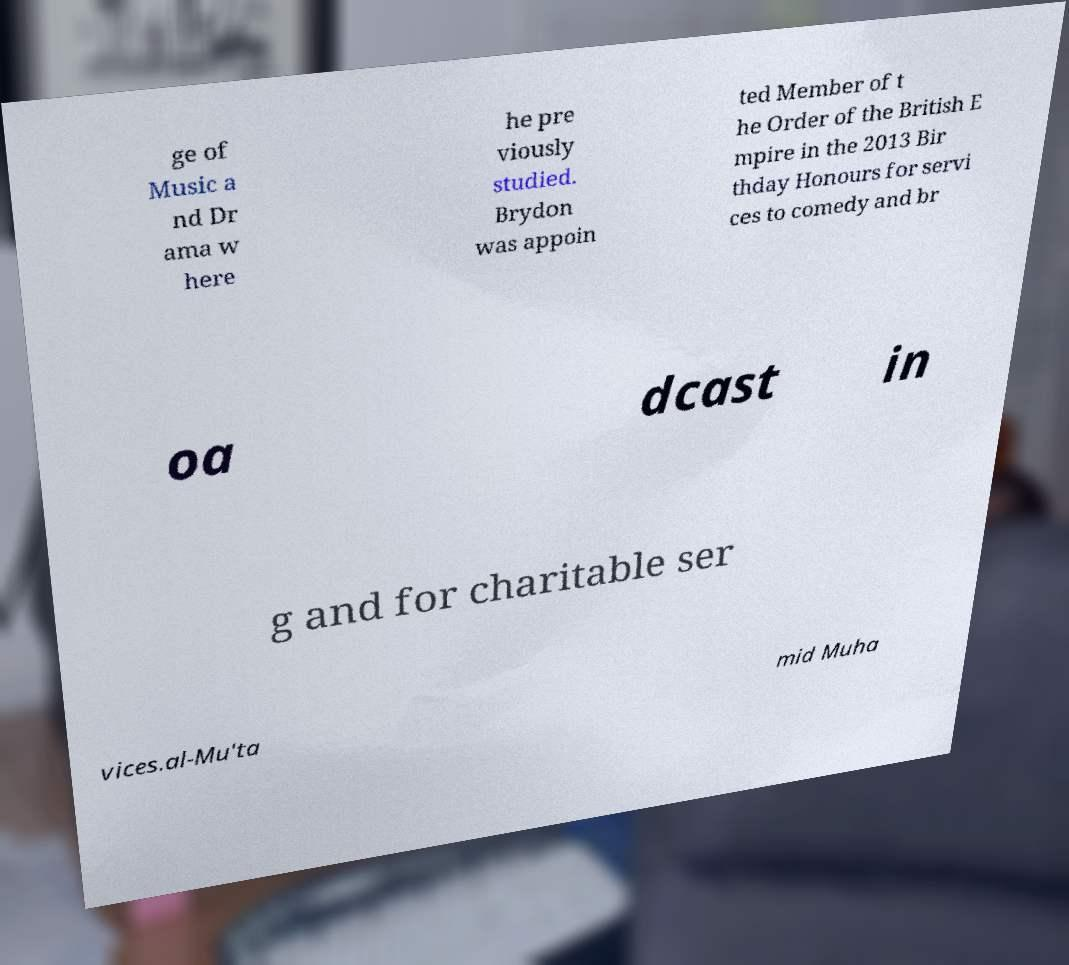What messages or text are displayed in this image? I need them in a readable, typed format. ge of Music a nd Dr ama w here he pre viously studied. Brydon was appoin ted Member of t he Order of the British E mpire in the 2013 Bir thday Honours for servi ces to comedy and br oa dcast in g and for charitable ser vices.al-Mu'ta mid Muha 